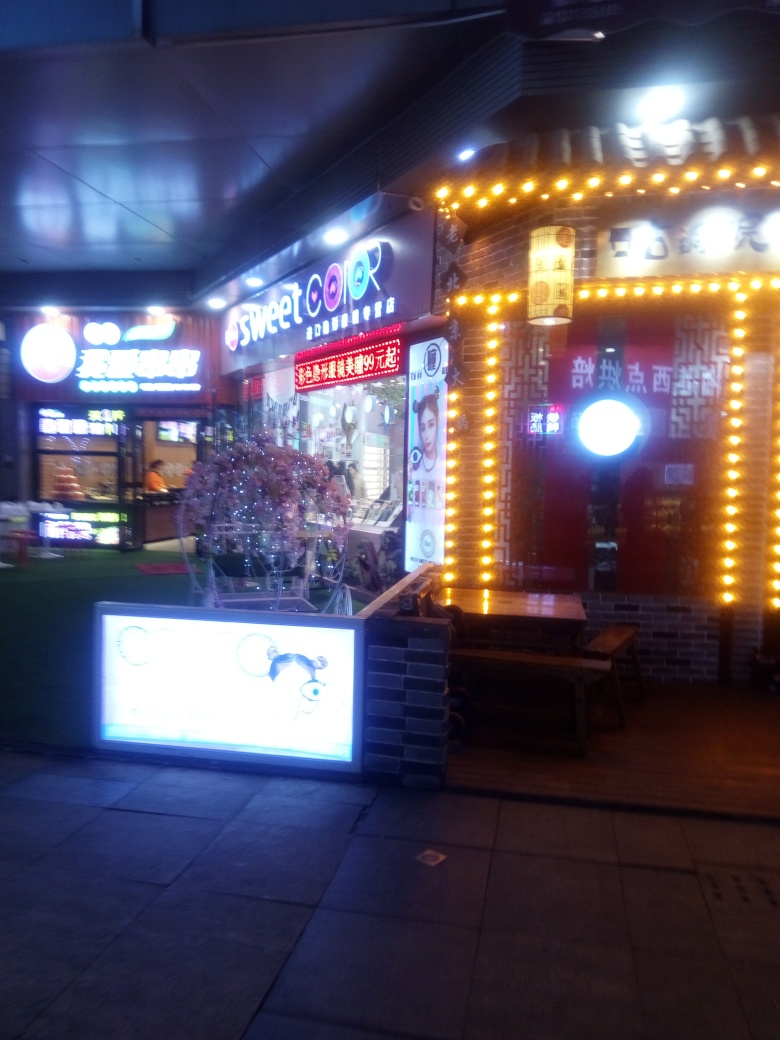What type of services do you think this place offers? With the name 'Sweet Color' prominently displayed and images of styling heads, it's quite evident that the establishment offers beauty salon services, specializing in hair coloring and styling. 